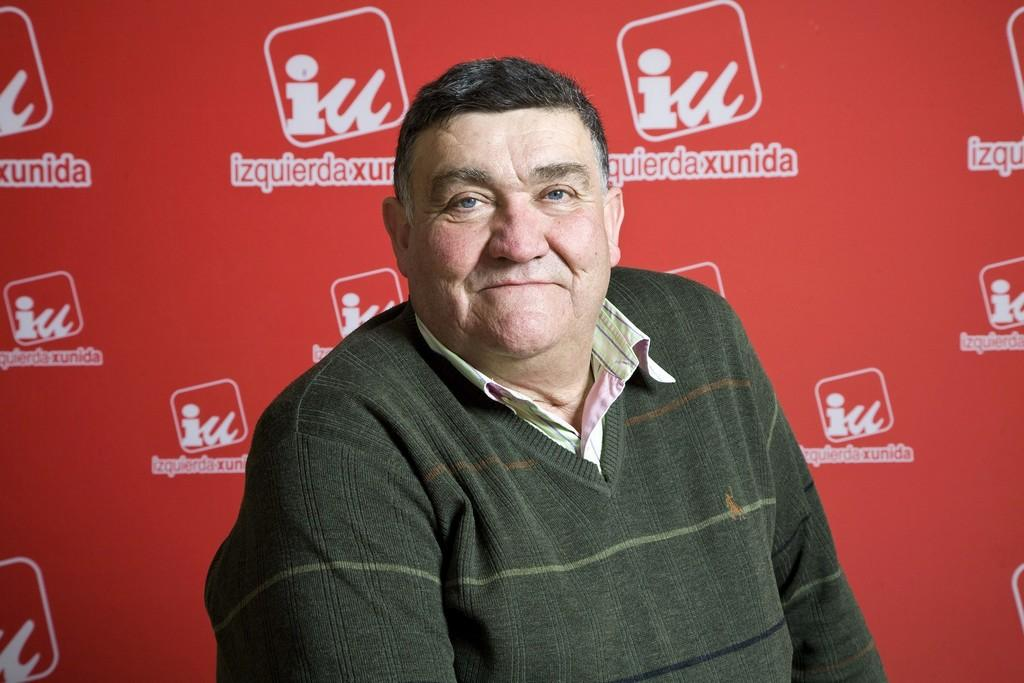What is the man in the image doing? The man is sitting on a chair in the image. What can be seen in the background of the image? There is a banner in the background of the image. What is written on the banner? There is text on the banner. What is featured on the banner besides the text? There is a logo on the banner. What type of roof can be seen on the building in the image? There is no building or roof visible in the image; it only features a man sitting on a chair and a banner in the background. 